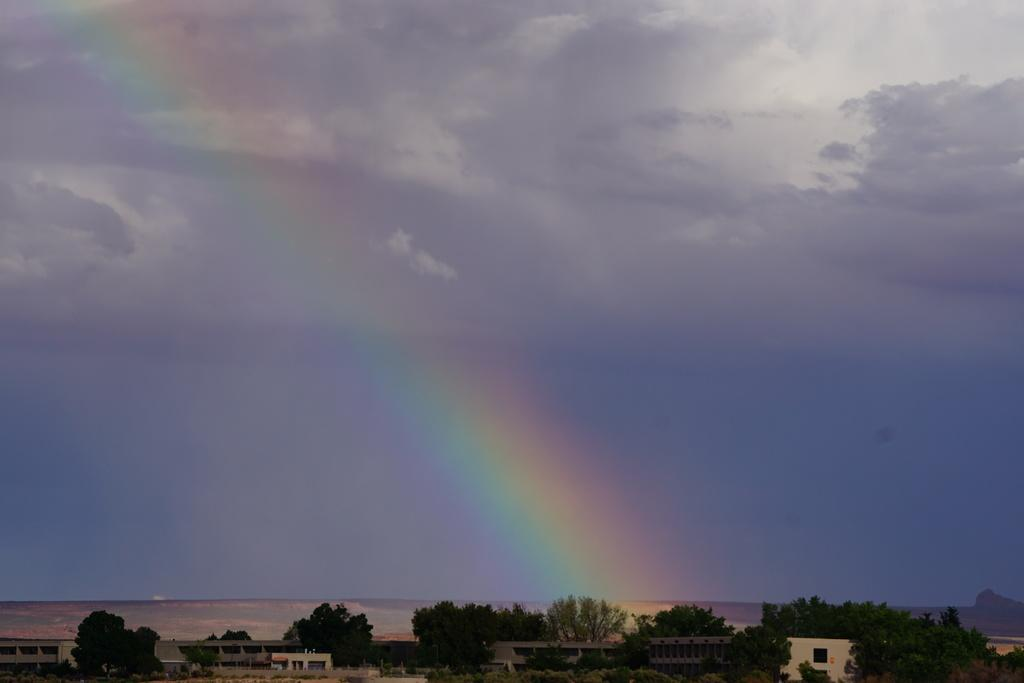What type of structures can be seen in the image? There are buildings in the image. What natural feature is present in the image? There is a mountain in the image. What type of vegetation can be seen in the image? There are trees, bushes, plants, and grass in the image. What is visible at the top of the image? The sky is visible at the top of the image. What is the weather like in the image? The sky is cloudy, and there is a rainbow in the sky. What type of soda is being served at the grandmother's house in the image? There is no mention of soda, a grandmother's house, or any serving in the image. What type of work is the laborer doing in the image? There is no laborer or any work being done in the image. 